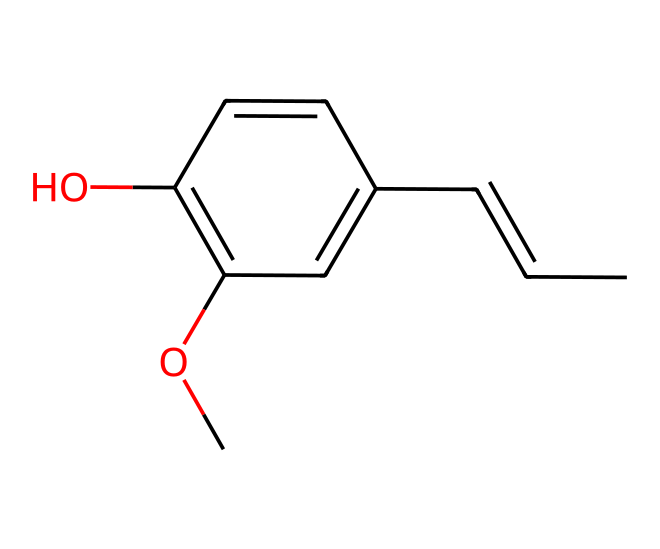What is the functional group present in eugenol? The structure shows a hydroxyl group (-OH) attached to a carbon atom, classifying it as a phenol.
Answer: hydroxyl group How many carbon atoms are in eugenol? By counting the carbon atoms in the SMILES representation, there are 10 carbon atoms in total.
Answer: 10 What type of organic compound is eugenol classified as? Based on its structure featuring a phenolic ring and a hydroxyl group, eugenol is classified as a phenol.
Answer: phenol How many double bonds are present in eugenol? The structure has two double bonds indicated in the rings and alkene parts, totaling two double bonds.
Answer: 2 Which part of eugenol is likely responsible for its aromatic properties? The benzene-like ring structure in eugenol is responsible for its aromatic properties, which is characteristic of phenolic compounds.
Answer: benzene-like ring What is the total number of hydrogen atoms in eugenol? By analyzing the hydrogen atoms associated with each carbon and considering the structure, eugenol has 12 hydrogen atoms.
Answer: 12 